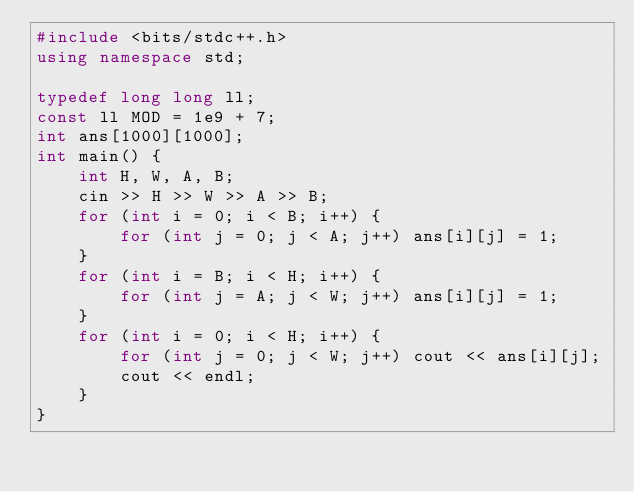Convert code to text. <code><loc_0><loc_0><loc_500><loc_500><_C++_>#include <bits/stdc++.h>
using namespace std;

typedef long long ll;
const ll MOD = 1e9 + 7;
int ans[1000][1000];
int main() {
	int H, W, A, B;
	cin >> H >> W >> A >> B;
	for (int i = 0; i < B; i++) {
		for (int j = 0; j < A; j++) ans[i][j] = 1;
	}
	for (int i = B; i < H; i++) {
		for (int j = A; j < W; j++) ans[i][j] = 1;
	}
	for (int i = 0; i < H; i++) {
		for (int j = 0; j < W; j++) cout << ans[i][j];
		cout << endl;
	}
}</code> 